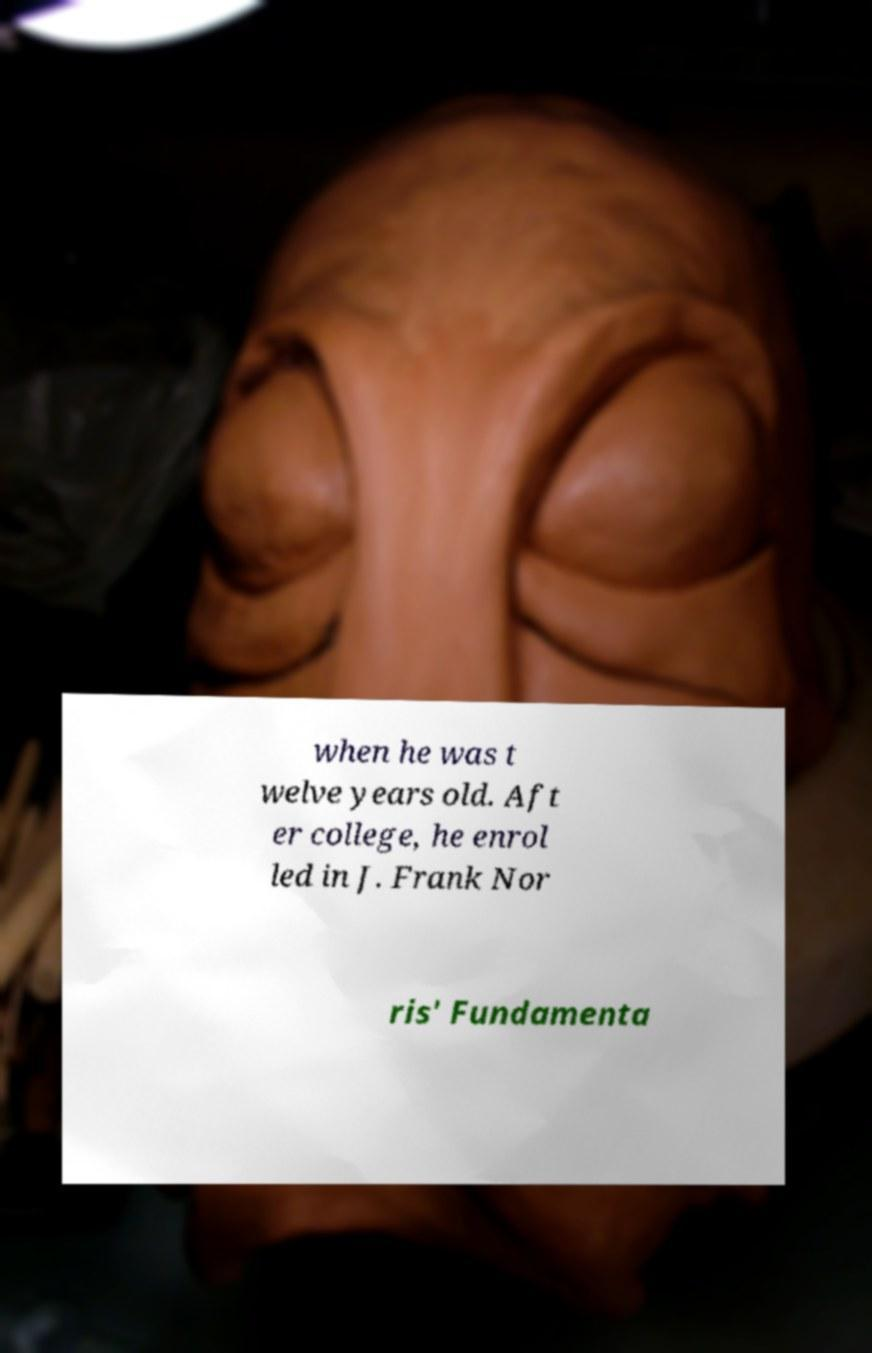There's text embedded in this image that I need extracted. Can you transcribe it verbatim? when he was t welve years old. Aft er college, he enrol led in J. Frank Nor ris' Fundamenta 